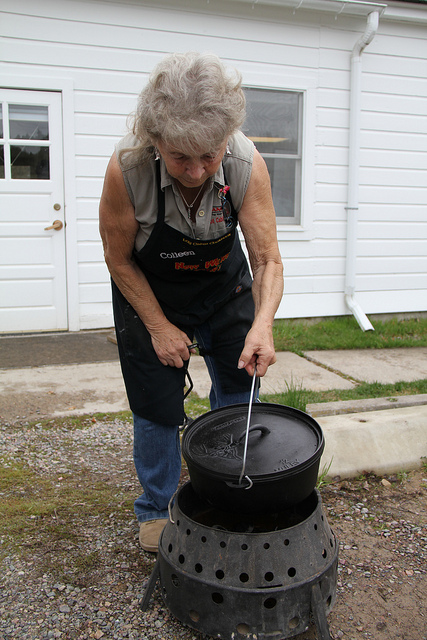<image>Is the woman hungry? It's ambiguous if the woman is hungry or not. Is the woman hungry? It is unclear whether the woman is hungry or not. 